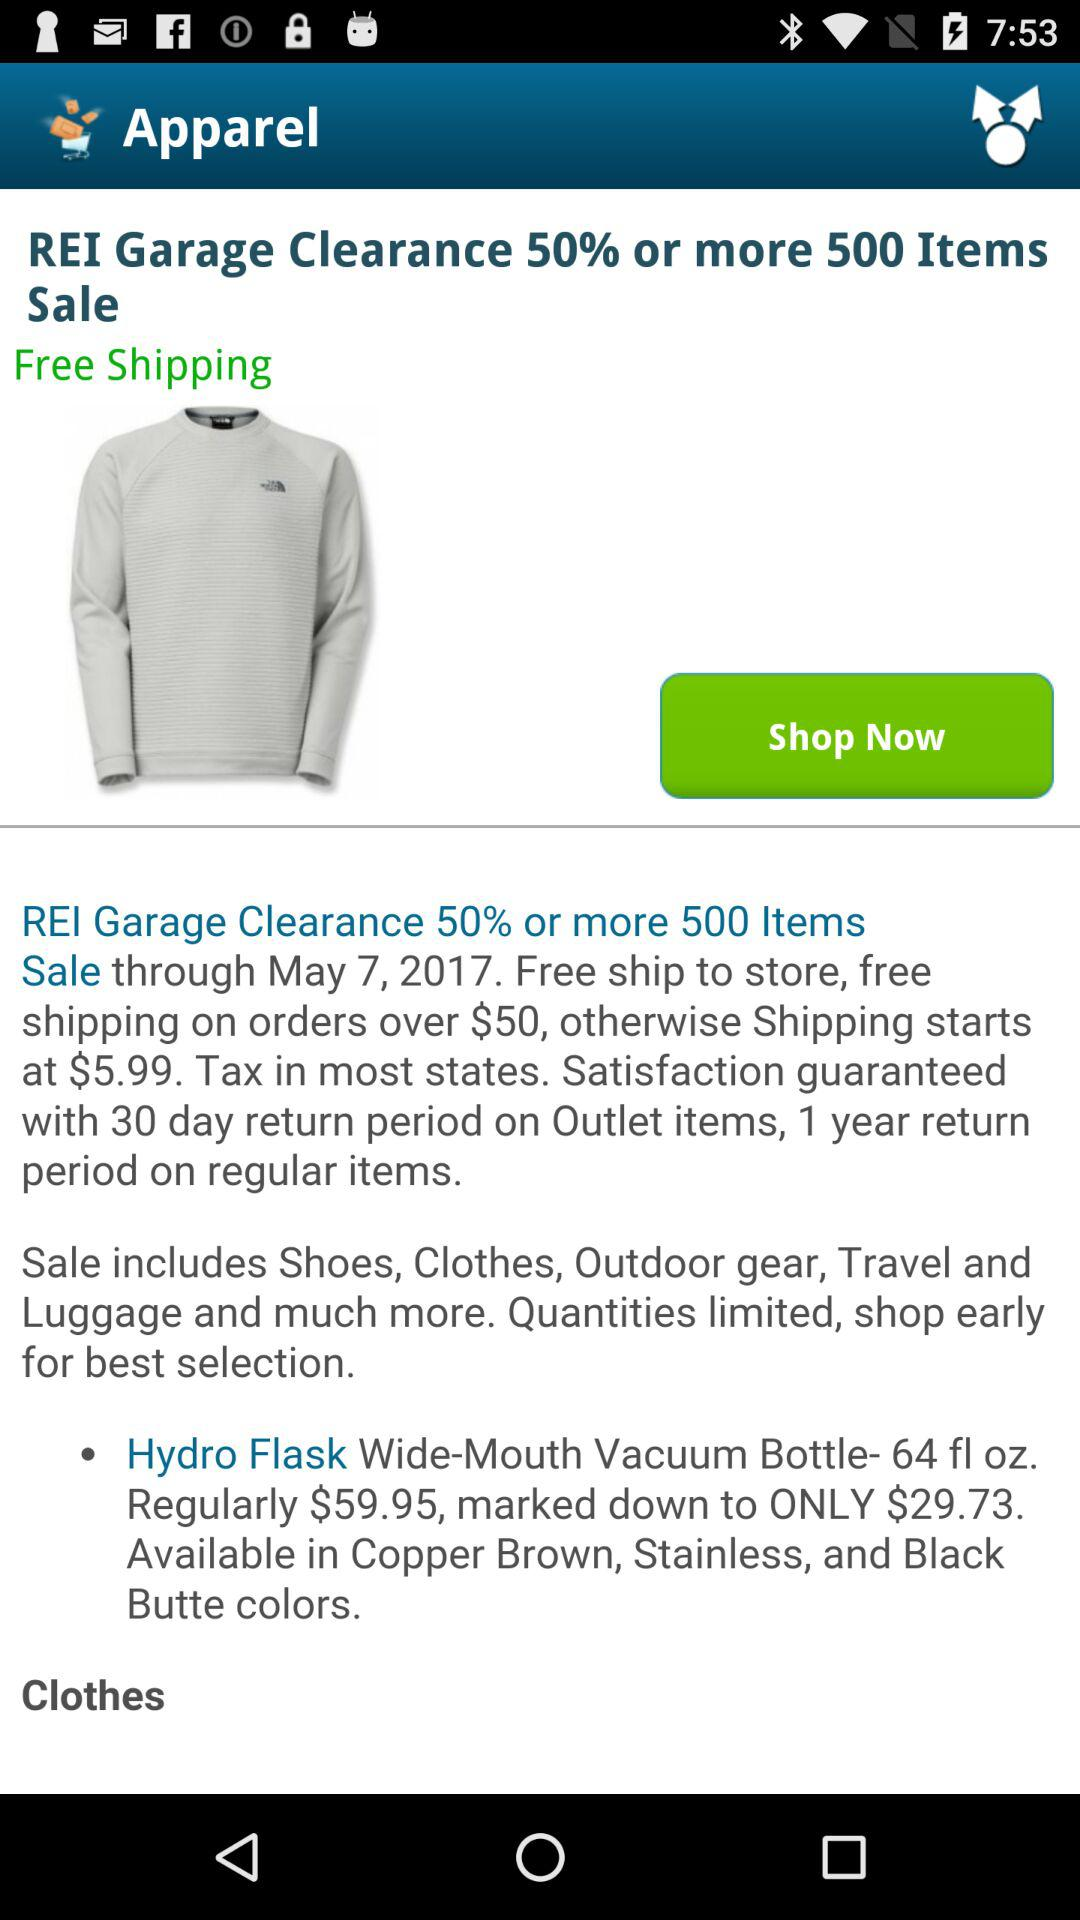What items does the clearance sale include? The items are shoes, clothes, outdoor gear, travel and luggage and much more. 